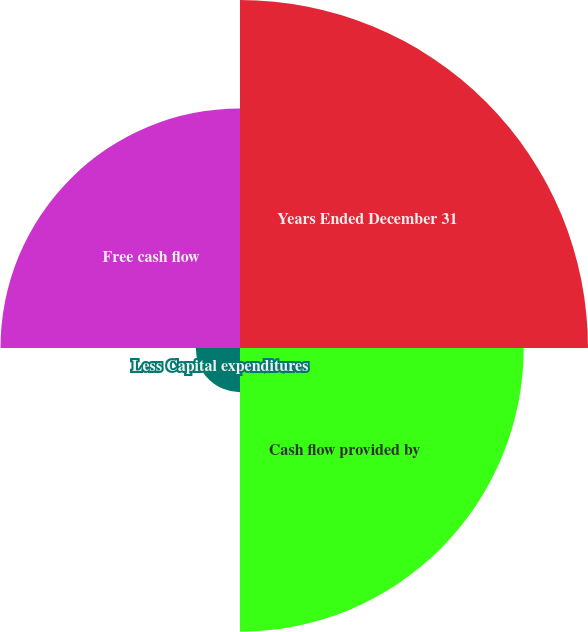Convert chart. <chart><loc_0><loc_0><loc_500><loc_500><pie_chart><fcel>Years Ended December 31<fcel>Cash flow provided by<fcel>Less Capital expenditures<fcel>Free cash flow<nl><fcel>38.01%<fcel>30.99%<fcel>4.83%<fcel>26.16%<nl></chart> 